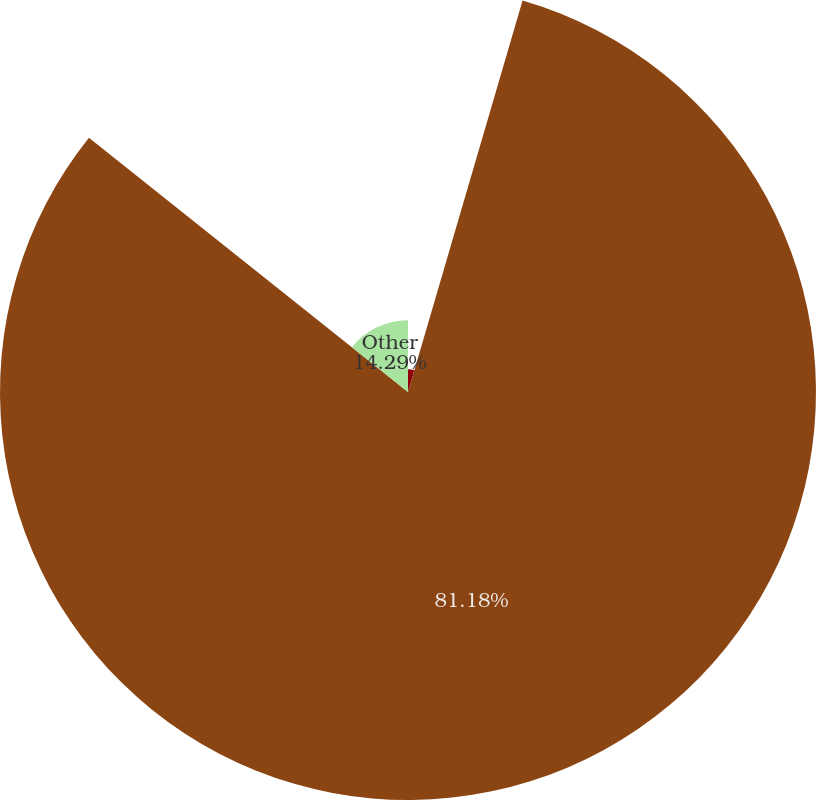Convert chart to OTSL. <chart><loc_0><loc_0><loc_500><loc_500><pie_chart><fcel>Foreigncurrency(gains)losses<fcel>Unnamed: 1<fcel>Other<nl><fcel>4.53%<fcel>81.18%<fcel>14.29%<nl></chart> 